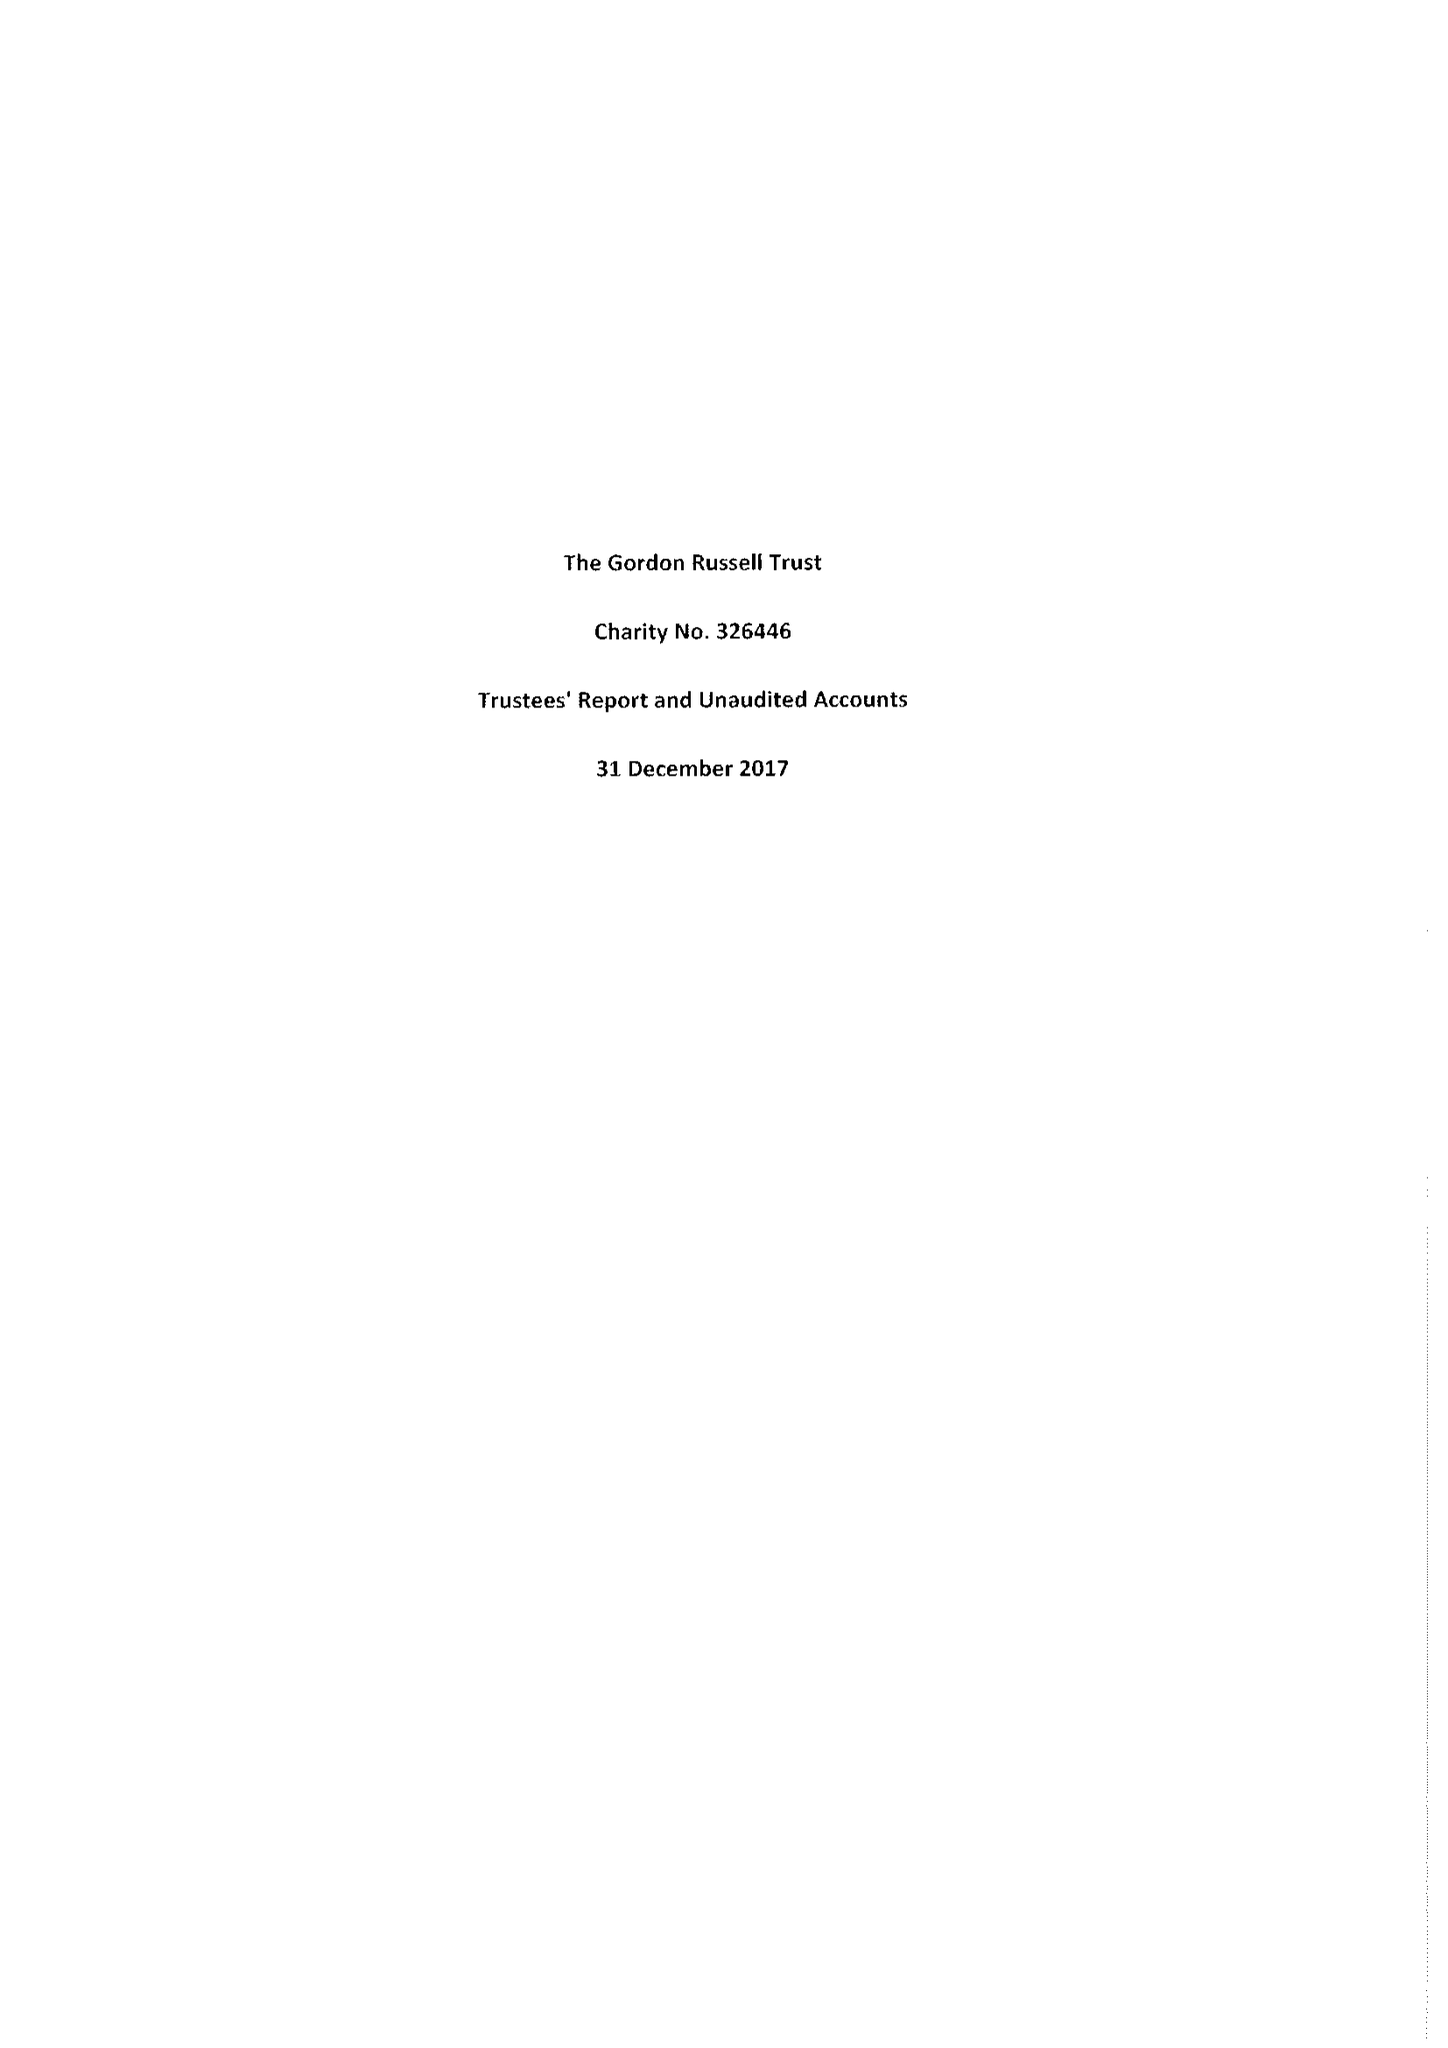What is the value for the spending_annually_in_british_pounds?
Answer the question using a single word or phrase. 74597.00 